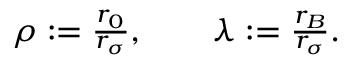Convert formula to latex. <formula><loc_0><loc_0><loc_500><loc_500>\begin{array} { r } { \rho \colon = { \frac { r _ { 0 } } { r _ { \sigma } } } , \quad \lambda \colon = { \frac { r _ { B } } { r _ { \sigma } } } . } \end{array}</formula> 